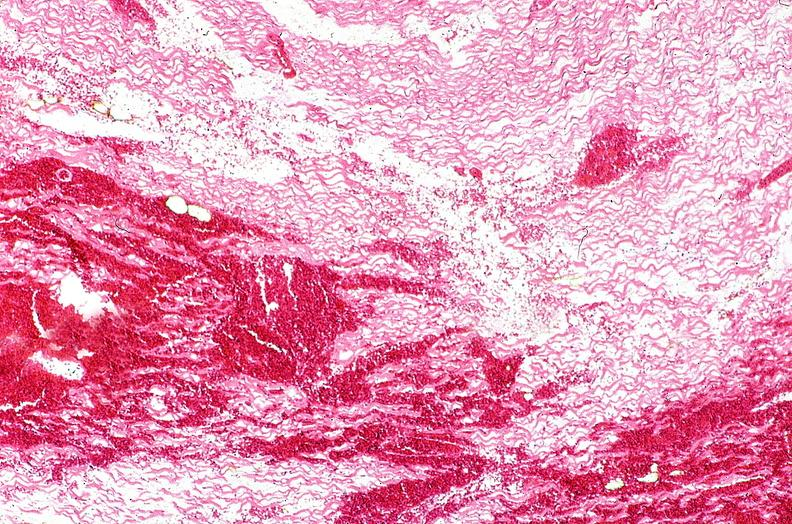does quite good liver show heart, myocardial infarction, wavey fiber change, necrtosis, hemorrhage, and dissection?
Answer the question using a single word or phrase. No 